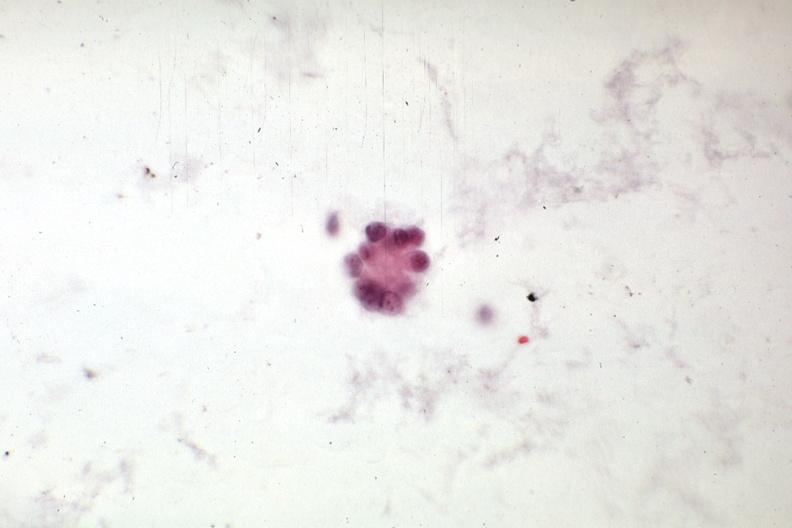what is present?
Answer the question using a single word or phrase. Peritoneal fluid 